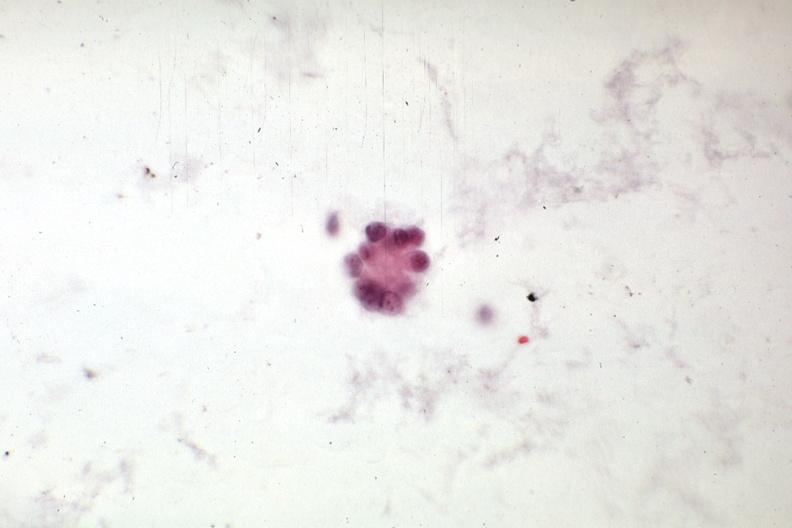what is present?
Answer the question using a single word or phrase. Peritoneal fluid 